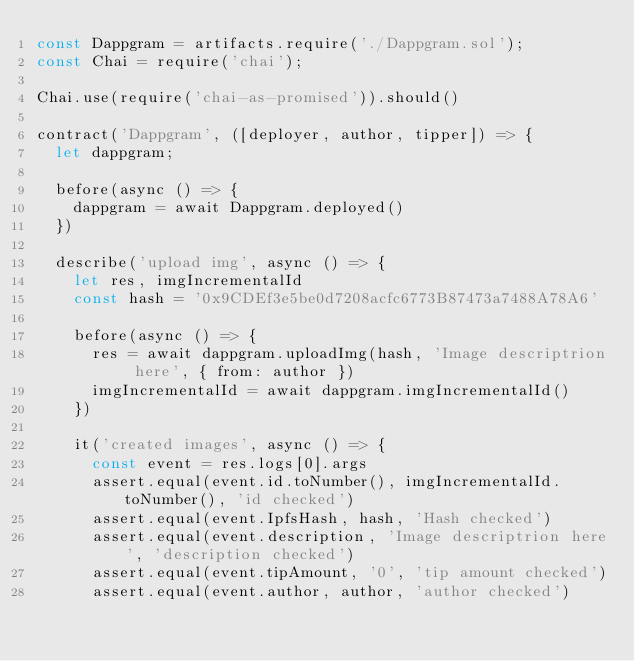<code> <loc_0><loc_0><loc_500><loc_500><_JavaScript_>const Dappgram = artifacts.require('./Dappgram.sol');
const Chai = require('chai');

Chai.use(require('chai-as-promised')).should()

contract('Dappgram', ([deployer, author, tipper]) => {
	let dappgram;

	before(async () => {
		dappgram = await Dappgram.deployed()
	})

	describe('upload img', async () => {
		let res, imgIncrementalId
		const hash = '0x9CDEf3e5be0d7208acfc6773B87473a7488A78A6'

		before(async () => {
			res = await dappgram.uploadImg(hash, 'Image descriptrion here', { from: author })
			imgIncrementalId = await dappgram.imgIncrementalId()
		})

		it('created images', async () => {
			const event = res.logs[0].args
			assert.equal(event.id.toNumber(), imgIncrementalId.toNumber(), 'id checked')
			assert.equal(event.IpfsHash, hash, 'Hash checked')
			assert.equal(event.description, 'Image descriptrion here', 'description checked')
			assert.equal(event.tipAmount, '0', 'tip amount checked')
			assert.equal(event.author, author, 'author checked')
</code> 